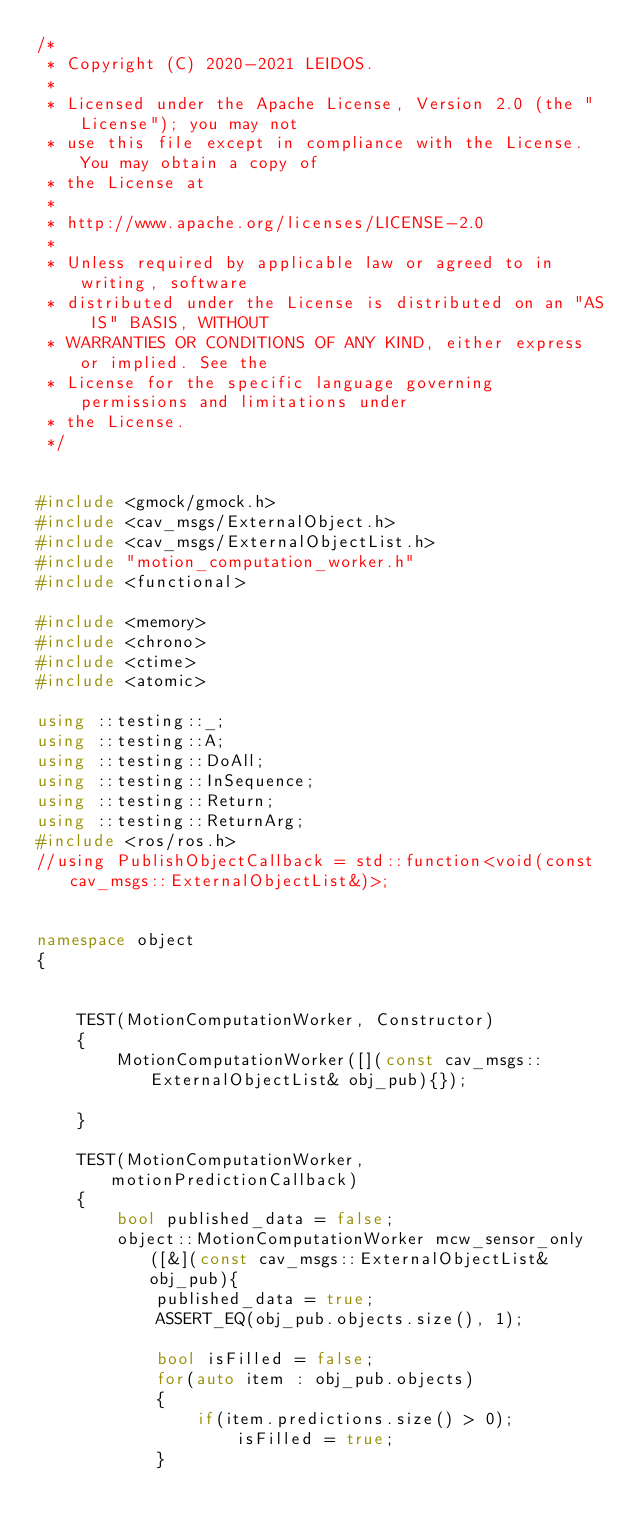<code> <loc_0><loc_0><loc_500><loc_500><_C++_>/*
 * Copyright (C) 2020-2021 LEIDOS.
 *
 * Licensed under the Apache License, Version 2.0 (the "License"); you may not
 * use this file except in compliance with the License. You may obtain a copy of
 * the License at
 *
 * http://www.apache.org/licenses/LICENSE-2.0
 *
 * Unless required by applicable law or agreed to in writing, software
 * distributed under the License is distributed on an "AS IS" BASIS, WITHOUT
 * WARRANTIES OR CONDITIONS OF ANY KIND, either express or implied. See the
 * License for the specific language governing permissions and limitations under
 * the License.
 */


#include <gmock/gmock.h>
#include <cav_msgs/ExternalObject.h>
#include <cav_msgs/ExternalObjectList.h>
#include "motion_computation_worker.h"  
#include <functional>

#include <memory>
#include <chrono>
#include <ctime>
#include <atomic>

using ::testing::_;
using ::testing::A;
using ::testing::DoAll;
using ::testing::InSequence;
using ::testing::Return;
using ::testing::ReturnArg;
#include <ros/ros.h>
//using PublishObjectCallback = std::function<void(const cav_msgs::ExternalObjectList&)>;


namespace object
{


    TEST(MotionComputationWorker, Constructor)
    {   
        MotionComputationWorker([](const cav_msgs::ExternalObjectList& obj_pub){});

    }

    TEST(MotionComputationWorker, motionPredictionCallback)
    {    
        bool published_data = false;
        object::MotionComputationWorker mcw_sensor_only([&](const cav_msgs::ExternalObjectList& obj_pub){
            published_data = true;
            ASSERT_EQ(obj_pub.objects.size(), 1);

            bool isFilled = false;
            for(auto item : obj_pub.objects)
            {
                if(item.predictions.size() > 0);
                    isFilled = true;
            }</code> 